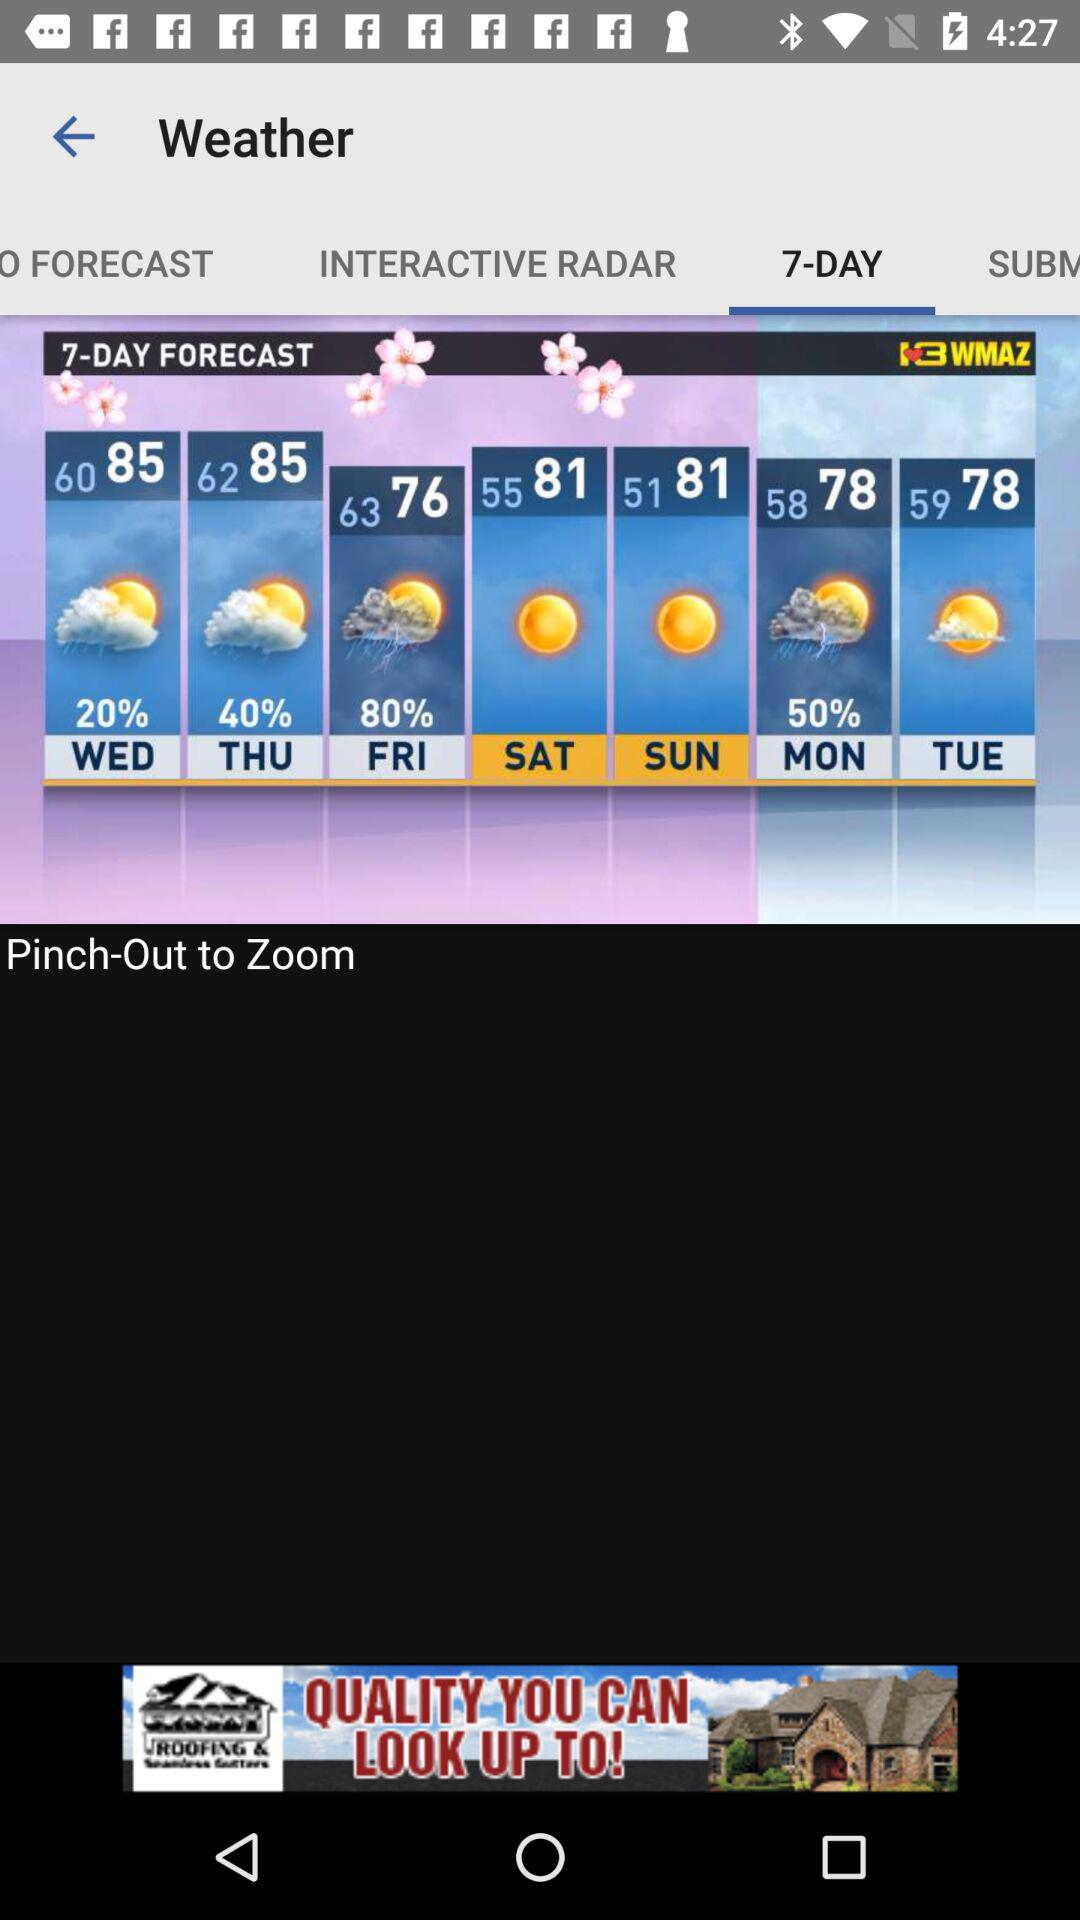What is the interactive radar?
When the provided information is insufficient, respond with <no answer>. <no answer> 